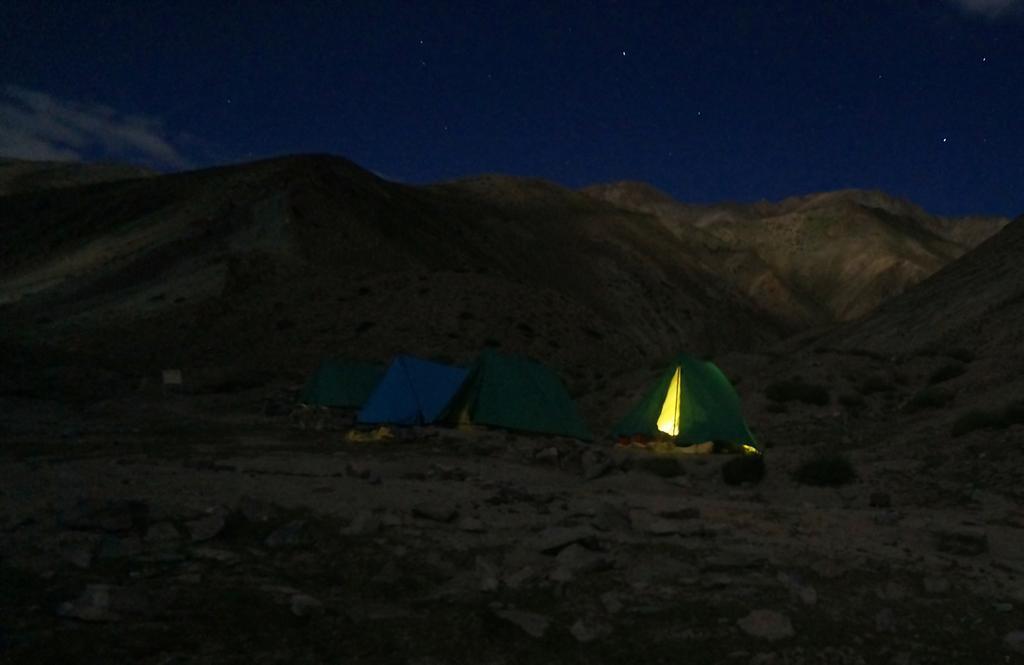How would you summarize this image in a sentence or two? In this image we can see there are tents on the ground and there is the light in the tent. And at the back there are mountains and the sky. 